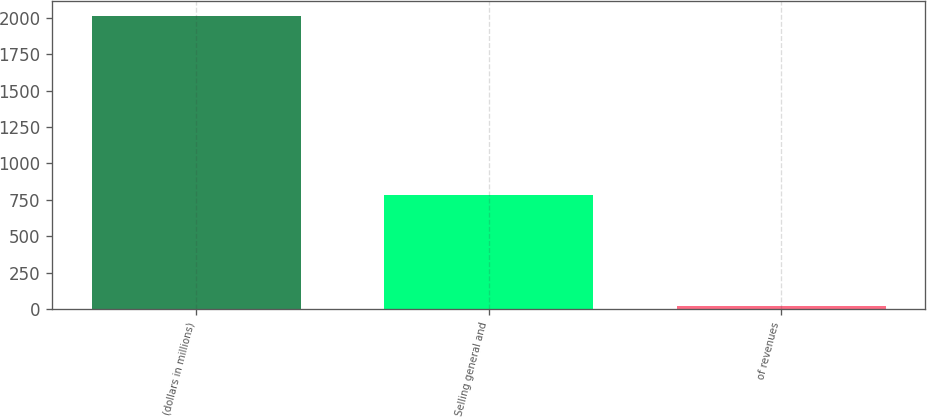Convert chart to OTSL. <chart><loc_0><loc_0><loc_500><loc_500><bar_chart><fcel>(dollars in millions)<fcel>Selling general and<fcel>of revenues<nl><fcel>2014<fcel>781<fcel>18.8<nl></chart> 